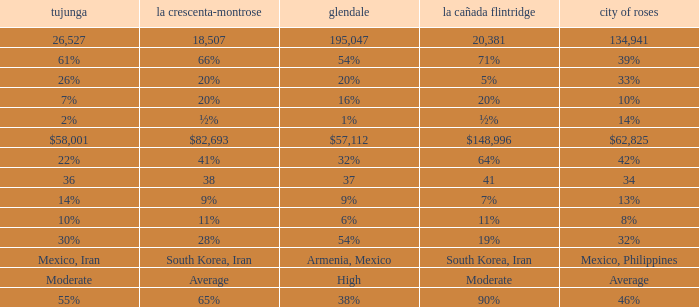When Tujunga is moderate, what is La Crescenta-Montrose? Average. 